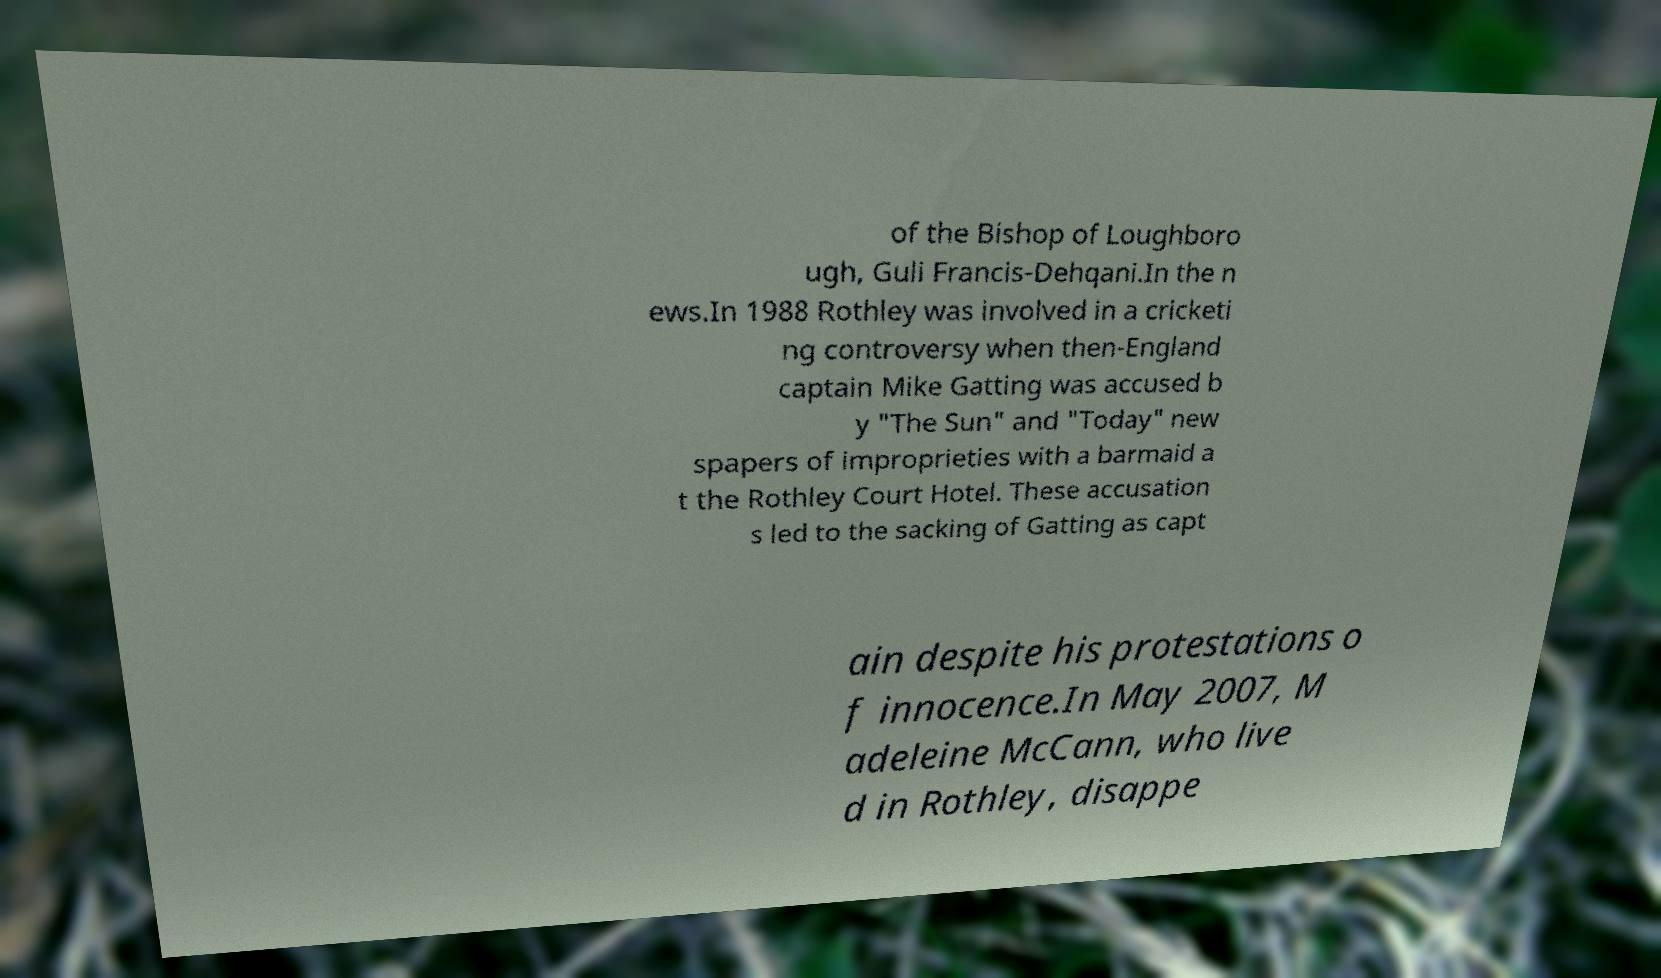There's text embedded in this image that I need extracted. Can you transcribe it verbatim? of the Bishop of Loughboro ugh, Guli Francis-Dehqani.In the n ews.In 1988 Rothley was involved in a cricketi ng controversy when then-England captain Mike Gatting was accused b y "The Sun" and "Today" new spapers of improprieties with a barmaid a t the Rothley Court Hotel. These accusation s led to the sacking of Gatting as capt ain despite his protestations o f innocence.In May 2007, M adeleine McCann, who live d in Rothley, disappe 